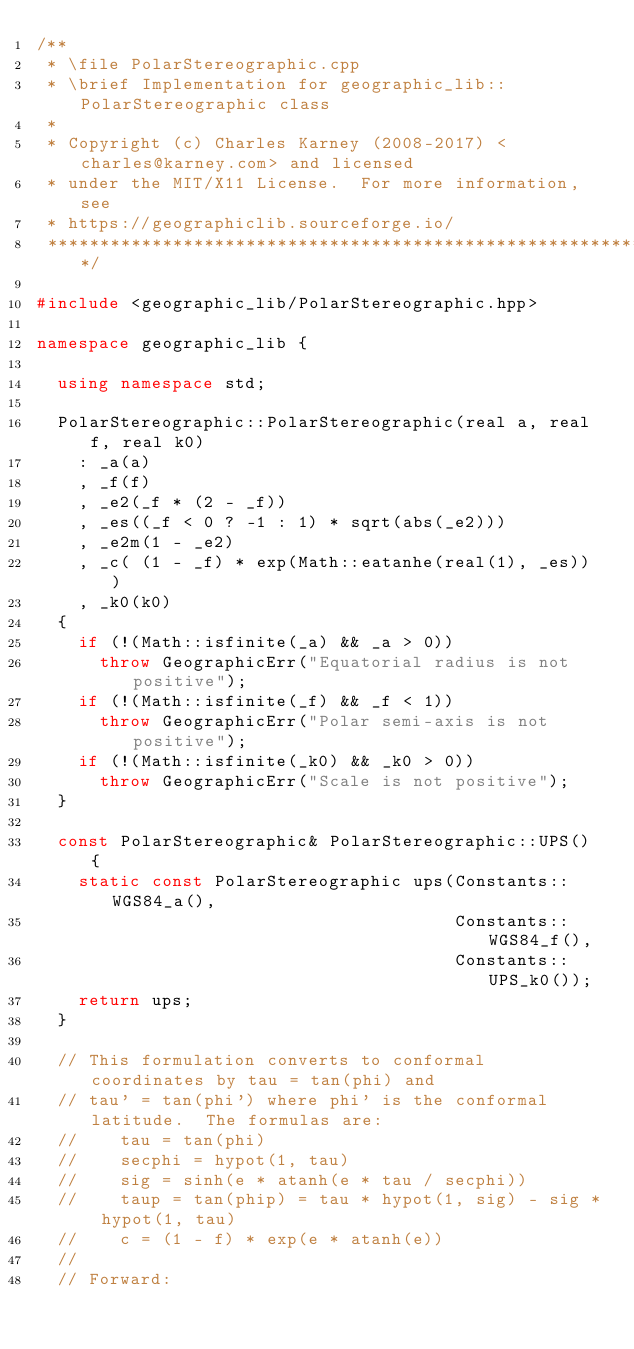<code> <loc_0><loc_0><loc_500><loc_500><_C++_>/**
 * \file PolarStereographic.cpp
 * \brief Implementation for geographic_lib::PolarStereographic class
 *
 * Copyright (c) Charles Karney (2008-2017) <charles@karney.com> and licensed
 * under the MIT/X11 License.  For more information, see
 * https://geographiclib.sourceforge.io/
 **********************************************************************/

#include <geographic_lib/PolarStereographic.hpp>

namespace geographic_lib {

  using namespace std;

  PolarStereographic::PolarStereographic(real a, real f, real k0)
    : _a(a)
    , _f(f)
    , _e2(_f * (2 - _f))
    , _es((_f < 0 ? -1 : 1) * sqrt(abs(_e2)))
    , _e2m(1 - _e2)
    , _c( (1 - _f) * exp(Math::eatanhe(real(1), _es)) )
    , _k0(k0)
  {
    if (!(Math::isfinite(_a) && _a > 0))
      throw GeographicErr("Equatorial radius is not positive");
    if (!(Math::isfinite(_f) && _f < 1))
      throw GeographicErr("Polar semi-axis is not positive");
    if (!(Math::isfinite(_k0) && _k0 > 0))
      throw GeographicErr("Scale is not positive");
  }

  const PolarStereographic& PolarStereographic::UPS() {
    static const PolarStereographic ups(Constants::WGS84_a(),
                                        Constants::WGS84_f(),
                                        Constants::UPS_k0());
    return ups;
  }

  // This formulation converts to conformal coordinates by tau = tan(phi) and
  // tau' = tan(phi') where phi' is the conformal latitude.  The formulas are:
  //    tau = tan(phi)
  //    secphi = hypot(1, tau)
  //    sig = sinh(e * atanh(e * tau / secphi))
  //    taup = tan(phip) = tau * hypot(1, sig) - sig * hypot(1, tau)
  //    c = (1 - f) * exp(e * atanh(e))
  //
  // Forward:</code> 